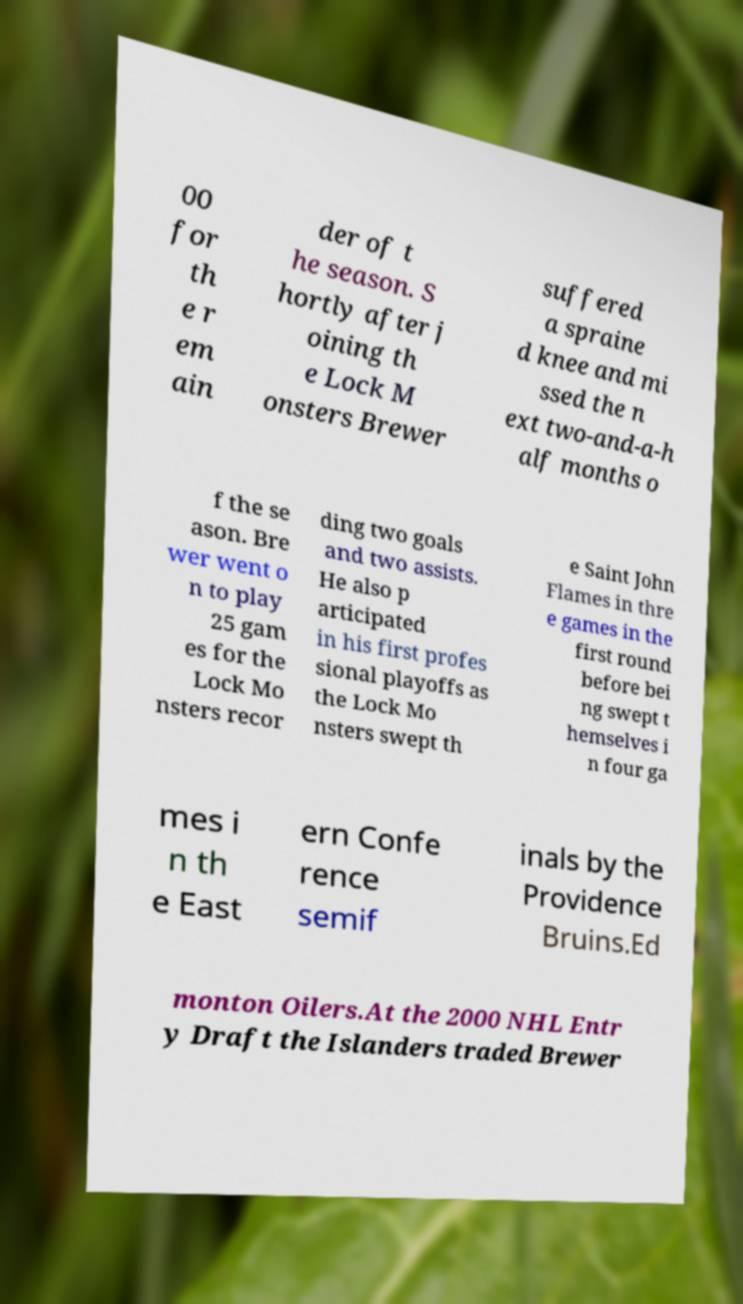Can you accurately transcribe the text from the provided image for me? 00 for th e r em ain der of t he season. S hortly after j oining th e Lock M onsters Brewer suffered a spraine d knee and mi ssed the n ext two-and-a-h alf months o f the se ason. Bre wer went o n to play 25 gam es for the Lock Mo nsters recor ding two goals and two assists. He also p articipated in his first profes sional playoffs as the Lock Mo nsters swept th e Saint John Flames in thre e games in the first round before bei ng swept t hemselves i n four ga mes i n th e East ern Confe rence semif inals by the Providence Bruins.Ed monton Oilers.At the 2000 NHL Entr y Draft the Islanders traded Brewer 